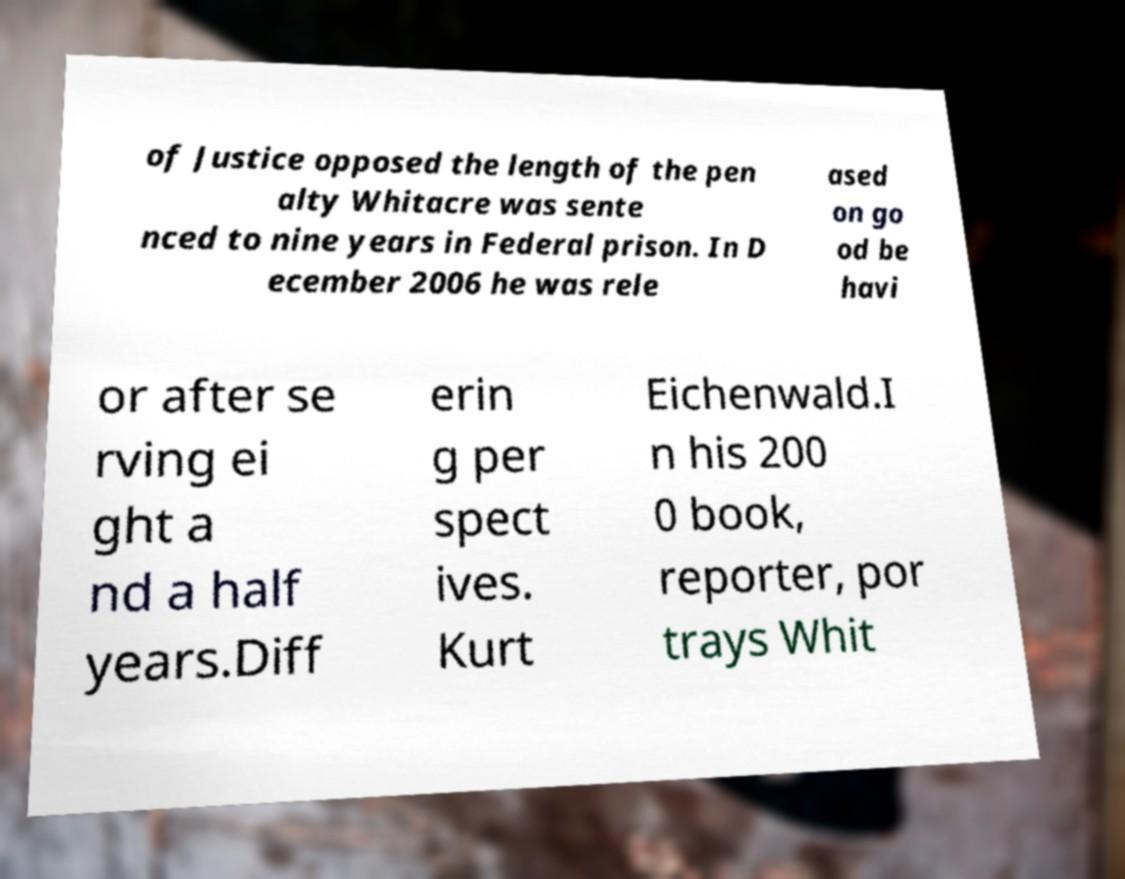Could you assist in decoding the text presented in this image and type it out clearly? of Justice opposed the length of the pen alty Whitacre was sente nced to nine years in Federal prison. In D ecember 2006 he was rele ased on go od be havi or after se rving ei ght a nd a half years.Diff erin g per spect ives. Kurt Eichenwald.I n his 200 0 book, reporter, por trays Whit 